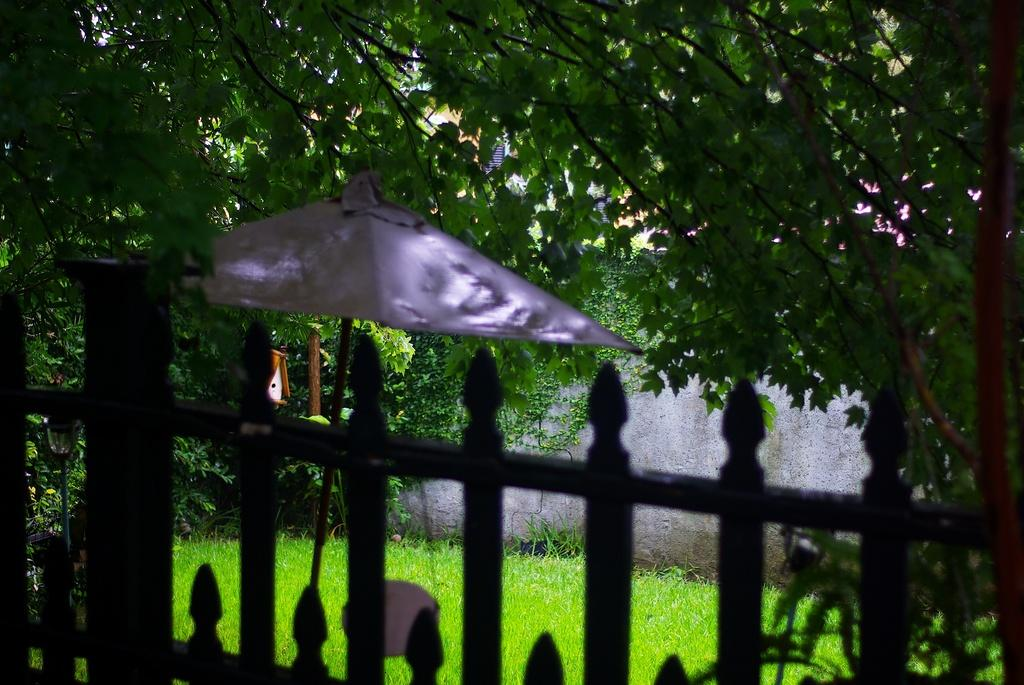What type of structure is present in the image? There is a grille in the image. What type of vegetation can be seen in the image? There is grass in the image. What type of object is present for providing shade? There is an umbrella in the image. What type of structure is present for birds? There is a bird house in the image. What type of material is used for the wooden object in the image? There is a wooden object in the image, but the specific material is not mentioned. What type of plant material is present in the image? There are leaves in the image. How can the bird house help the leaves in the image? The bird house is not related to the leaves in the image, so it cannot help them. 